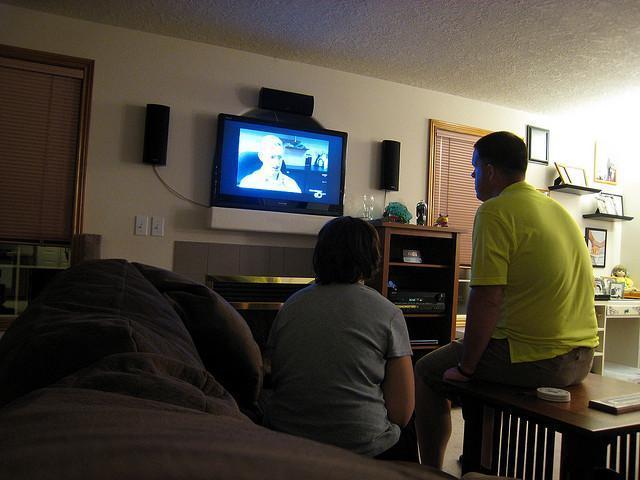How many light switches are there?
Give a very brief answer. 2. How many people are in the photo?
Give a very brief answer. 2. 